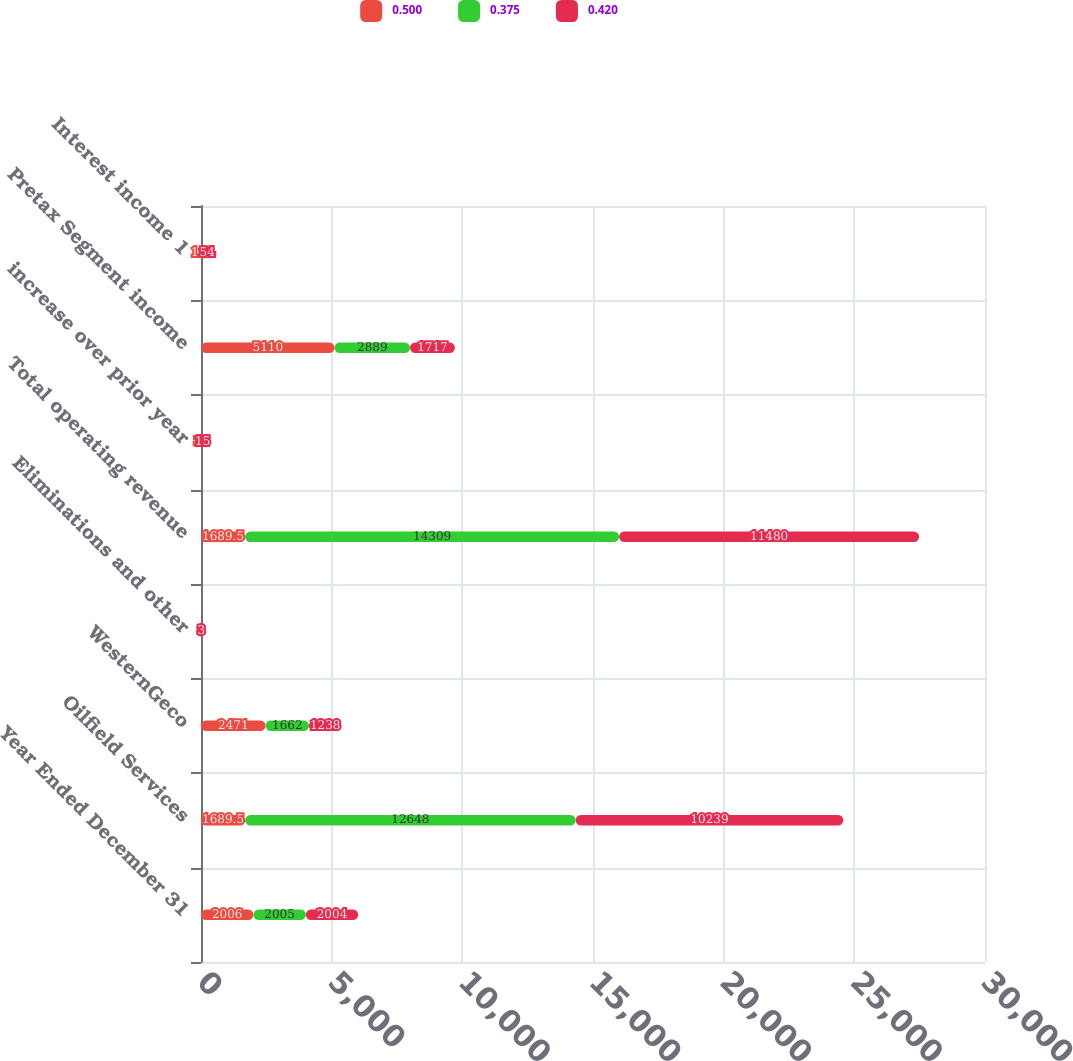Convert chart to OTSL. <chart><loc_0><loc_0><loc_500><loc_500><stacked_bar_chart><ecel><fcel>Year Ended December 31<fcel>Oilfield Services<fcel>WesternGeco<fcel>Eliminations and other<fcel>Total operating revenue<fcel>increase over prior year<fcel>Pretax Segment income<fcel>Interest income 1<nl><fcel>0.5<fcel>2006<fcel>1689.5<fcel>2471<fcel>8<fcel>1689.5<fcel>34<fcel>5110<fcel>113<nl><fcel>0.375<fcel>2005<fcel>12648<fcel>1662<fcel>1<fcel>14309<fcel>25<fcel>2889<fcel>98<nl><fcel>0.42<fcel>2004<fcel>10239<fcel>1238<fcel>3<fcel>11480<fcel>15<fcel>1717<fcel>54<nl></chart> 